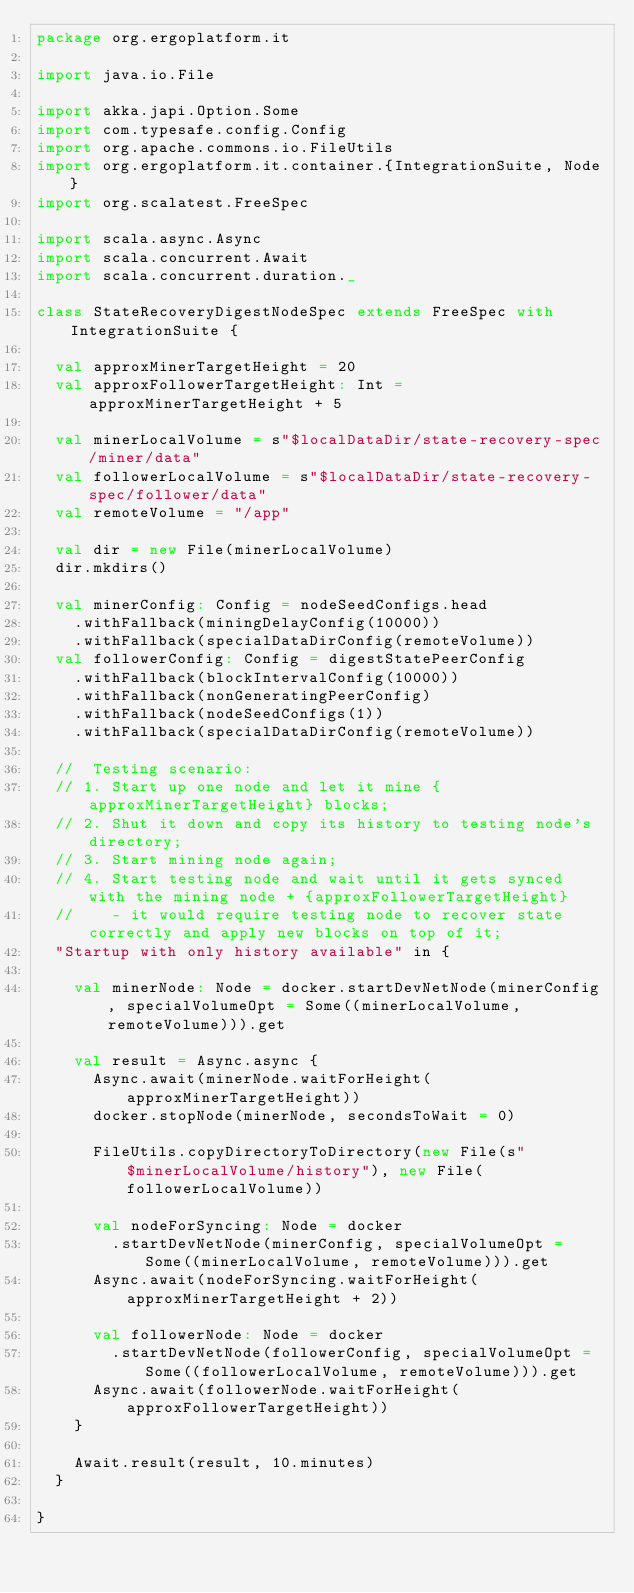Convert code to text. <code><loc_0><loc_0><loc_500><loc_500><_Scala_>package org.ergoplatform.it

import java.io.File

import akka.japi.Option.Some
import com.typesafe.config.Config
import org.apache.commons.io.FileUtils
import org.ergoplatform.it.container.{IntegrationSuite, Node}
import org.scalatest.FreeSpec

import scala.async.Async
import scala.concurrent.Await
import scala.concurrent.duration._

class StateRecoveryDigestNodeSpec extends FreeSpec with IntegrationSuite {

  val approxMinerTargetHeight = 20
  val approxFollowerTargetHeight: Int = approxMinerTargetHeight + 5

  val minerLocalVolume = s"$localDataDir/state-recovery-spec/miner/data"
  val followerLocalVolume = s"$localDataDir/state-recovery-spec/follower/data"
  val remoteVolume = "/app"

  val dir = new File(minerLocalVolume)
  dir.mkdirs()

  val minerConfig: Config = nodeSeedConfigs.head
    .withFallback(miningDelayConfig(10000))
    .withFallback(specialDataDirConfig(remoteVolume))
  val followerConfig: Config = digestStatePeerConfig
    .withFallback(blockIntervalConfig(10000))
    .withFallback(nonGeneratingPeerConfig)
    .withFallback(nodeSeedConfigs(1))
    .withFallback(specialDataDirConfig(remoteVolume))

  //  Testing scenario:
  // 1. Start up one node and let it mine {approxMinerTargetHeight} blocks;
  // 2. Shut it down and copy its history to testing node's directory;
  // 3. Start mining node again;
  // 4. Start testing node and wait until it gets synced with the mining node + {approxFollowerTargetHeight}
  //    - it would require testing node to recover state correctly and apply new blocks on top of it;
  "Startup with only history available" in {

    val minerNode: Node = docker.startDevNetNode(minerConfig, specialVolumeOpt = Some((minerLocalVolume, remoteVolume))).get

    val result = Async.async {
      Async.await(minerNode.waitForHeight(approxMinerTargetHeight))
      docker.stopNode(minerNode, secondsToWait = 0)

      FileUtils.copyDirectoryToDirectory(new File(s"$minerLocalVolume/history"), new File(followerLocalVolume))

      val nodeForSyncing: Node = docker
        .startDevNetNode(minerConfig, specialVolumeOpt = Some((minerLocalVolume, remoteVolume))).get
      Async.await(nodeForSyncing.waitForHeight(approxMinerTargetHeight + 2))

      val followerNode: Node = docker
        .startDevNetNode(followerConfig, specialVolumeOpt = Some((followerLocalVolume, remoteVolume))).get
      Async.await(followerNode.waitForHeight(approxFollowerTargetHeight))
    }

    Await.result(result, 10.minutes)
  }

}
</code> 